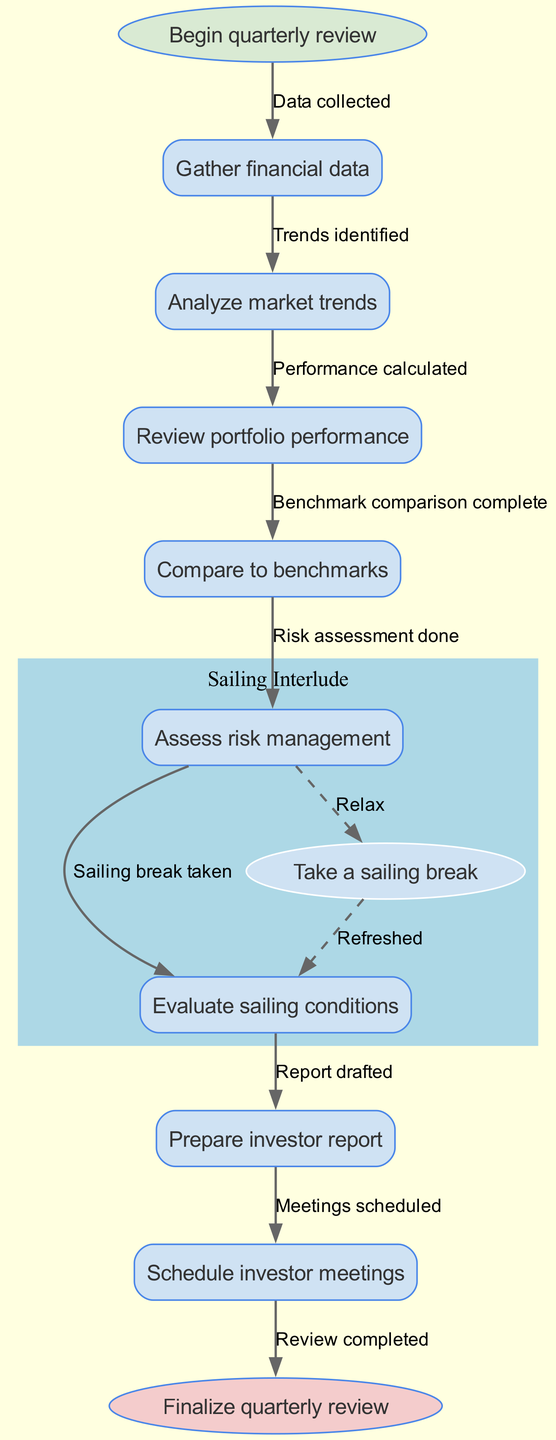What is the first step in the quarterly review workflow? The chart indicates that the first step is to "Gather financial data." This is the initial action taken before proceeding to further analysis.
Answer: Gather financial data How many nodes are present in the diagram? The diagram lists eight process nodes in total, which include steps from gathering data to scheduling meetings. Counting the start and end nodes gives a total of ten nodes in the entire workflow.
Answer: 10 What is the outcome after "Assess risk management"? The diagram illustrates that after assessing risk management, the next step is to "Evaluate sailing conditions." This means the workflow moves from risk assessment directly to evaluating conditions, indicating a possible break or interlude in the process.
Answer: Evaluate sailing conditions What type of break is mentioned in the diagram? The diagram includes a step labeled "Take a sailing break" which suggests that during the workflow, a pause for sailing is proposed. This introduces a recreational aspect to the quarterly review process, reflecting on personal enjoyment.
Answer: Sailing break What is the last step in the workflow? According to the flowchart, the final step in the quarterly performance review workflow is to "Finalize quarterly review." This denotes that all previous actions lead up to this concluding phase where the review is completed.
Answer: Finalize quarterly review Which node connects risk assessment to the sailing break? The flowchart shows that the "Assess risk management" node connects to the "Take a sailing break" node. This indicates that after reviewing risk management, there's an opportunity to take a break for sailing.
Answer: Assess risk management How many edges are there leading to the end node? The end node is approached through one main path from the final process node, making the total number of edges that lead to the end node one. Therefore, there is one edge connecting to the finalization of the quarterly review.
Answer: 1 What does the sailing-themed subgraph indicate? The subgraph labeled "Sailing Interlude" indicates that there's a dedicated part of the workflow focused on taking a break for sailing. This highlights an important balance between work and leisure within the performance review process.
Answer: Take a sailing break 